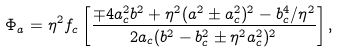Convert formula to latex. <formula><loc_0><loc_0><loc_500><loc_500>\Phi _ { a } = \eta ^ { 2 } f _ { c } \left [ \frac { \mp 4 a _ { c } ^ { 2 } b ^ { 2 } + \eta ^ { 2 } ( a ^ { 2 } \pm a _ { c } ^ { 2 } ) ^ { 2 } - b _ { c } ^ { 4 } / \eta ^ { 2 } } { 2 a _ { c } ( b ^ { 2 } - b _ { c } ^ { 2 } \pm \eta ^ { 2 } a _ { c } ^ { 2 } ) ^ { 2 } } \right ] ,</formula> 